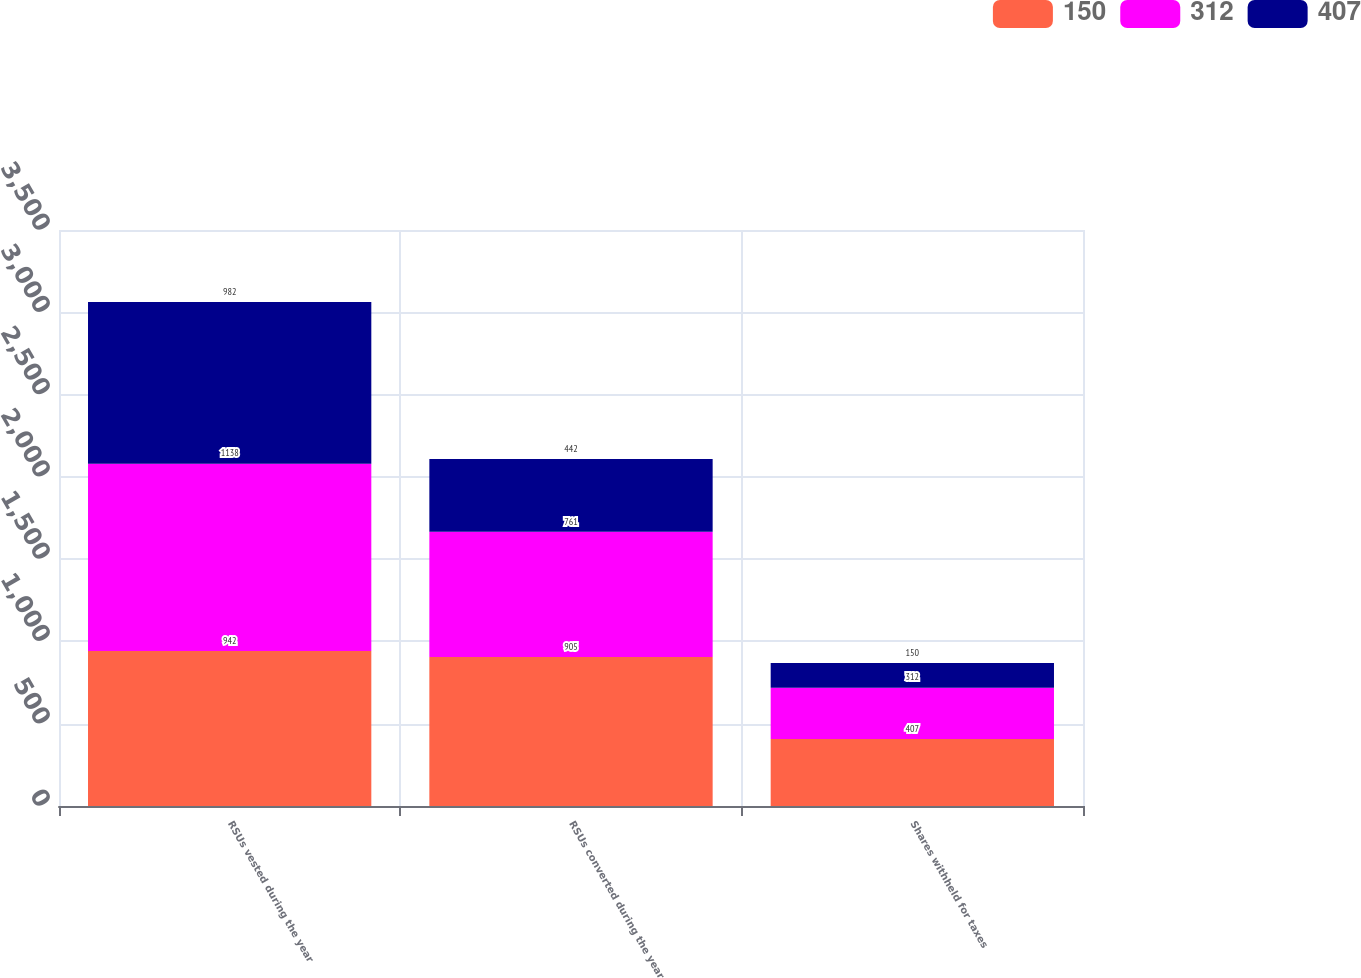<chart> <loc_0><loc_0><loc_500><loc_500><stacked_bar_chart><ecel><fcel>RSUs vested during the year<fcel>RSUs converted during the year<fcel>Shares withheld for taxes<nl><fcel>150<fcel>942<fcel>905<fcel>407<nl><fcel>312<fcel>1138<fcel>761<fcel>312<nl><fcel>407<fcel>982<fcel>442<fcel>150<nl></chart> 